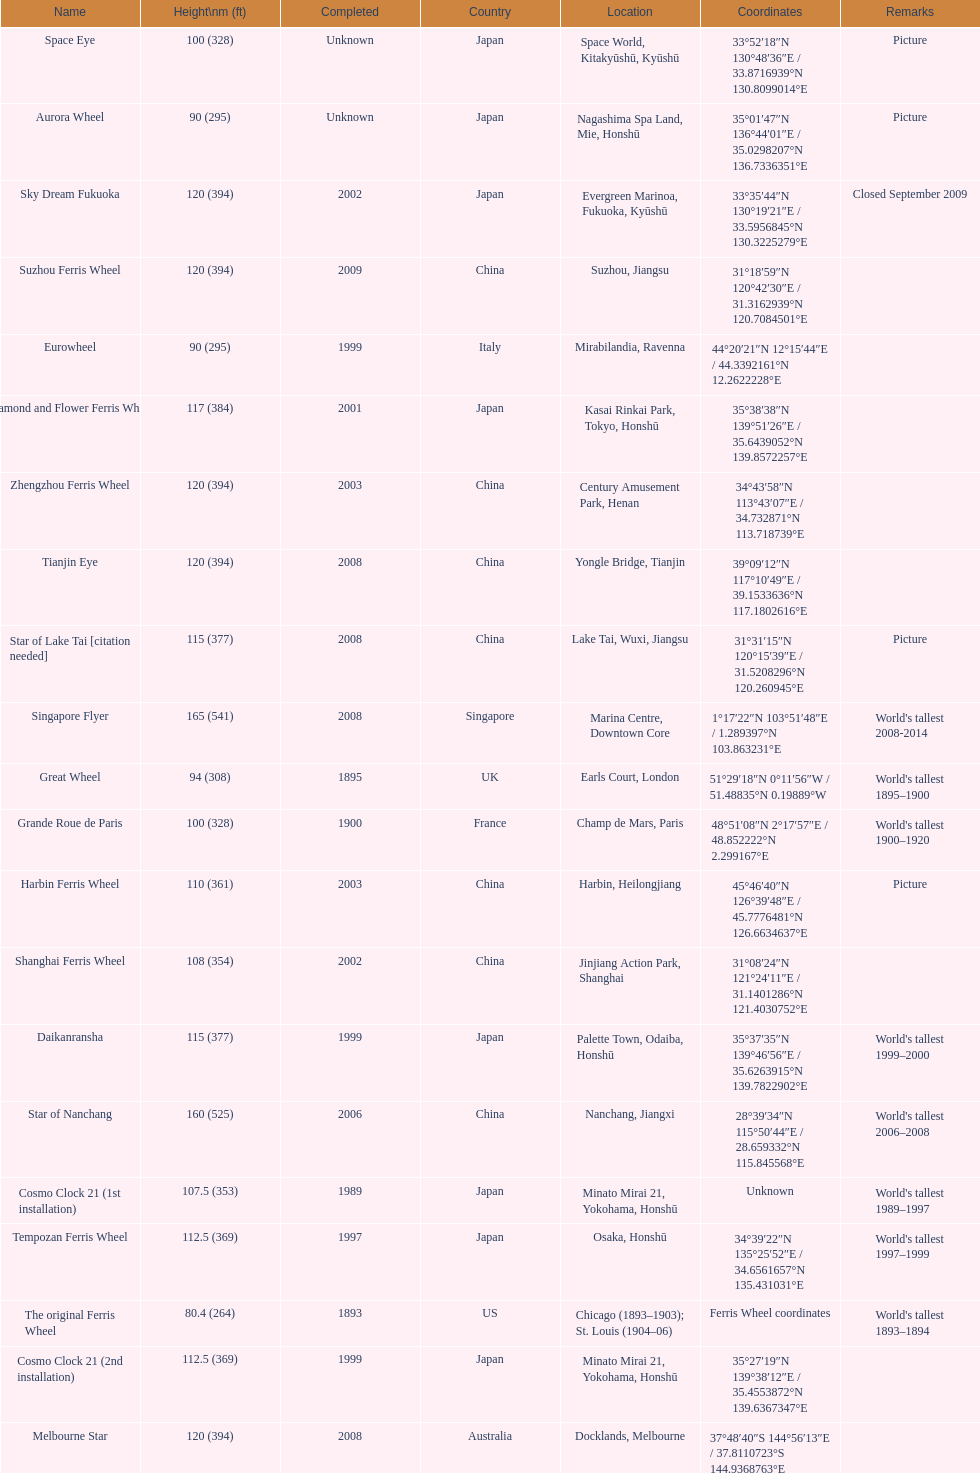Which of the following roller coasters is the oldest: star of lake tai, star of nanchang, melbourne star Star of Nanchang. 